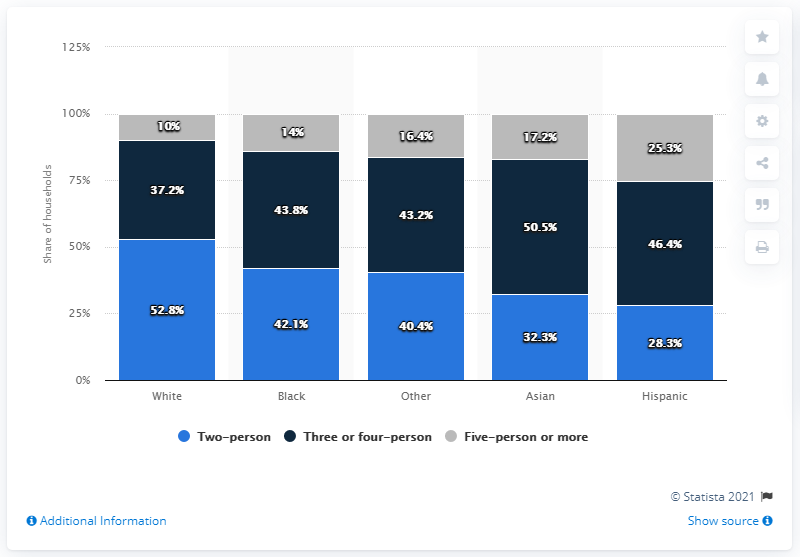Outline some significant characteristics in this image. In 2015, approximately 28.3% of Hispanic households were made up of two people. The percentage of black residents in a two-person household is 42.1%. The difference between the percentage of blacks and whites in a resident of Two-person is 10.7%. 